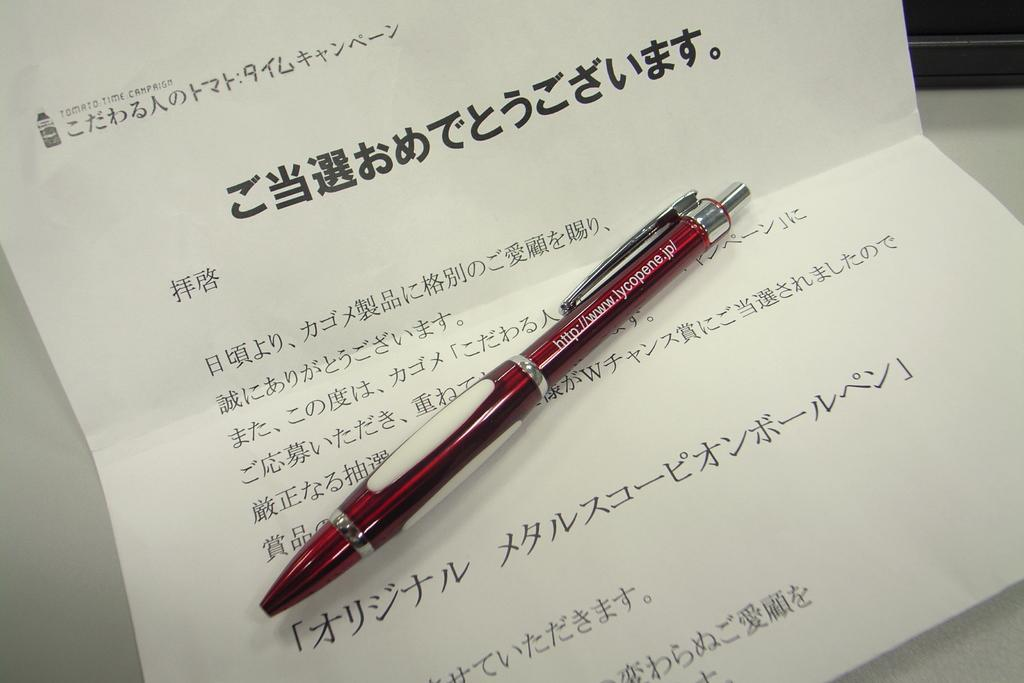What object is present in the image that is used for writing? There is a red pen in the image. What is the pen placed on in the image? The pen is on a white paper. Is there any text or markings visible on the paper? Yes, there is writing on the paper. What type of drink is being served in the image? There is no drink present in the image; it only features a red pen on a white paper with writing. How long does it take for the coal to burn out in the image? There is no coal present in the image, so it is not possible to determine how long it would take for it to burn out. 